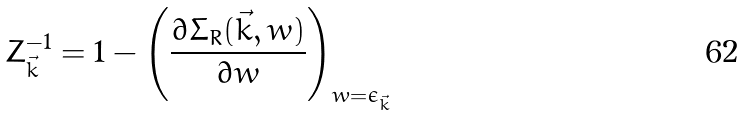<formula> <loc_0><loc_0><loc_500><loc_500>Z _ { \vec { k } } ^ { - 1 } = 1 - \left ( \frac { \partial \Sigma _ { R } ( \vec { k } , w ) } { \partial w } \right ) _ { w = \epsilon _ { \vec { k } } }</formula> 